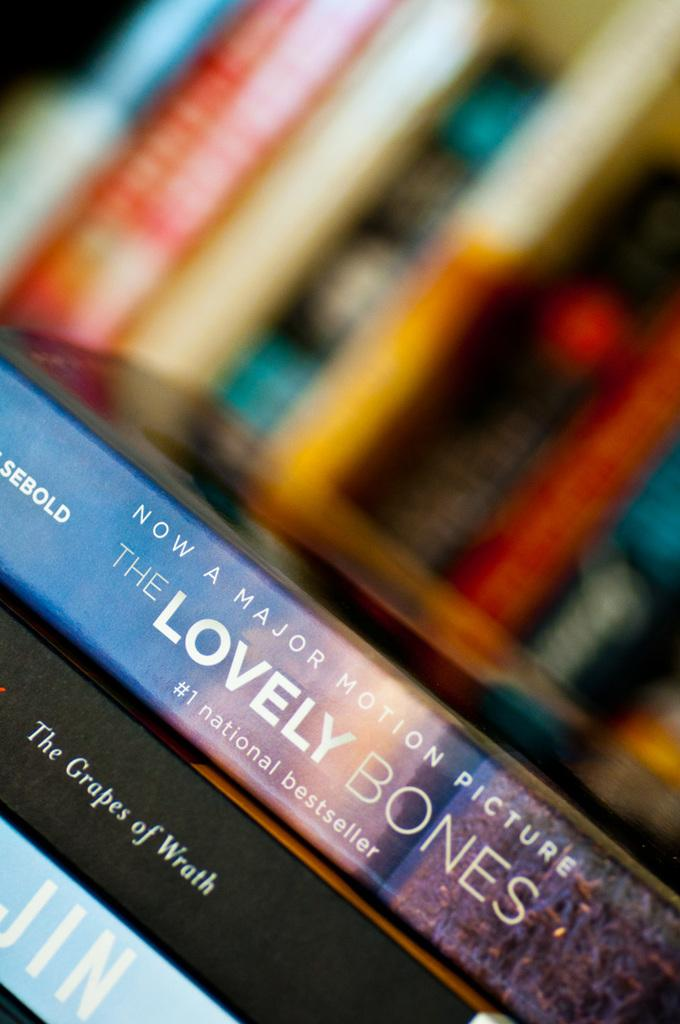Provide a one-sentence caption for the provided image. Movie spines are lined up, the most visible The Grapes of Wrath and The Lovely Bones. 